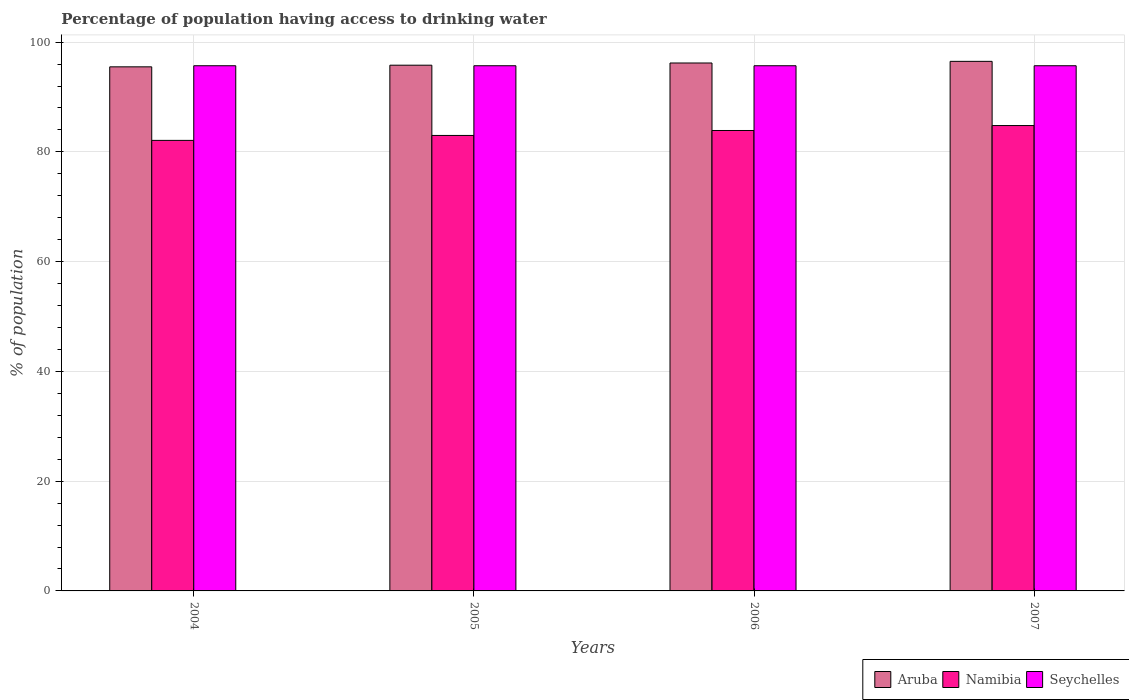How many groups of bars are there?
Your answer should be compact. 4. Are the number of bars on each tick of the X-axis equal?
Offer a very short reply. Yes. How many bars are there on the 4th tick from the left?
Your response must be concise. 3. In how many cases, is the number of bars for a given year not equal to the number of legend labels?
Keep it short and to the point. 0. What is the percentage of population having access to drinking water in Namibia in 2007?
Make the answer very short. 84.8. Across all years, what is the maximum percentage of population having access to drinking water in Namibia?
Your response must be concise. 84.8. Across all years, what is the minimum percentage of population having access to drinking water in Seychelles?
Your answer should be compact. 95.7. In which year was the percentage of population having access to drinking water in Aruba minimum?
Give a very brief answer. 2004. What is the total percentage of population having access to drinking water in Aruba in the graph?
Ensure brevity in your answer.  384. What is the difference between the percentage of population having access to drinking water in Aruba in 2004 and that in 2007?
Give a very brief answer. -1. What is the difference between the percentage of population having access to drinking water in Aruba in 2007 and the percentage of population having access to drinking water in Namibia in 2006?
Ensure brevity in your answer.  12.6. What is the average percentage of population having access to drinking water in Aruba per year?
Offer a very short reply. 96. In the year 2006, what is the difference between the percentage of population having access to drinking water in Namibia and percentage of population having access to drinking water in Seychelles?
Provide a short and direct response. -11.8. In how many years, is the percentage of population having access to drinking water in Seychelles greater than 92 %?
Offer a very short reply. 4. What is the ratio of the percentage of population having access to drinking water in Namibia in 2006 to that in 2007?
Your answer should be compact. 0.99. Is the percentage of population having access to drinking water in Namibia in 2004 less than that in 2007?
Your answer should be compact. Yes. Is the difference between the percentage of population having access to drinking water in Namibia in 2005 and 2006 greater than the difference between the percentage of population having access to drinking water in Seychelles in 2005 and 2006?
Make the answer very short. No. What is the difference between the highest and the second highest percentage of population having access to drinking water in Namibia?
Keep it short and to the point. 0.9. What is the difference between the highest and the lowest percentage of population having access to drinking water in Seychelles?
Ensure brevity in your answer.  0. What does the 2nd bar from the left in 2005 represents?
Your response must be concise. Namibia. What does the 2nd bar from the right in 2004 represents?
Ensure brevity in your answer.  Namibia. How many bars are there?
Provide a succinct answer. 12. How many years are there in the graph?
Your answer should be very brief. 4. Does the graph contain grids?
Offer a terse response. Yes. Where does the legend appear in the graph?
Your response must be concise. Bottom right. How many legend labels are there?
Keep it short and to the point. 3. How are the legend labels stacked?
Your answer should be very brief. Horizontal. What is the title of the graph?
Make the answer very short. Percentage of population having access to drinking water. Does "Slovenia" appear as one of the legend labels in the graph?
Provide a short and direct response. No. What is the label or title of the X-axis?
Offer a terse response. Years. What is the label or title of the Y-axis?
Keep it short and to the point. % of population. What is the % of population in Aruba in 2004?
Provide a succinct answer. 95.5. What is the % of population in Namibia in 2004?
Your answer should be compact. 82.1. What is the % of population of Seychelles in 2004?
Provide a short and direct response. 95.7. What is the % of population of Aruba in 2005?
Your answer should be compact. 95.8. What is the % of population of Seychelles in 2005?
Your response must be concise. 95.7. What is the % of population in Aruba in 2006?
Your response must be concise. 96.2. What is the % of population of Namibia in 2006?
Offer a very short reply. 83.9. What is the % of population of Seychelles in 2006?
Provide a short and direct response. 95.7. What is the % of population in Aruba in 2007?
Offer a very short reply. 96.5. What is the % of population of Namibia in 2007?
Your response must be concise. 84.8. What is the % of population in Seychelles in 2007?
Ensure brevity in your answer.  95.7. Across all years, what is the maximum % of population in Aruba?
Provide a short and direct response. 96.5. Across all years, what is the maximum % of population of Namibia?
Keep it short and to the point. 84.8. Across all years, what is the maximum % of population in Seychelles?
Make the answer very short. 95.7. Across all years, what is the minimum % of population in Aruba?
Offer a very short reply. 95.5. Across all years, what is the minimum % of population in Namibia?
Provide a short and direct response. 82.1. Across all years, what is the minimum % of population in Seychelles?
Offer a terse response. 95.7. What is the total % of population in Aruba in the graph?
Give a very brief answer. 384. What is the total % of population in Namibia in the graph?
Your response must be concise. 333.8. What is the total % of population in Seychelles in the graph?
Your response must be concise. 382.8. What is the difference between the % of population of Aruba in 2004 and that in 2005?
Your response must be concise. -0.3. What is the difference between the % of population of Aruba in 2004 and that in 2006?
Ensure brevity in your answer.  -0.7. What is the difference between the % of population in Namibia in 2004 and that in 2006?
Your answer should be very brief. -1.8. What is the difference between the % of population of Seychelles in 2004 and that in 2006?
Ensure brevity in your answer.  0. What is the difference between the % of population in Namibia in 2004 and that in 2007?
Make the answer very short. -2.7. What is the difference between the % of population of Seychelles in 2004 and that in 2007?
Keep it short and to the point. 0. What is the difference between the % of population in Aruba in 2005 and that in 2006?
Your response must be concise. -0.4. What is the difference between the % of population of Namibia in 2005 and that in 2007?
Provide a succinct answer. -1.8. What is the difference between the % of population in Aruba in 2004 and the % of population in Seychelles in 2005?
Ensure brevity in your answer.  -0.2. What is the difference between the % of population in Namibia in 2004 and the % of population in Seychelles in 2005?
Your answer should be compact. -13.6. What is the difference between the % of population in Aruba in 2004 and the % of population in Namibia in 2006?
Provide a succinct answer. 11.6. What is the difference between the % of population in Aruba in 2004 and the % of population in Seychelles in 2006?
Your response must be concise. -0.2. What is the difference between the % of population of Namibia in 2004 and the % of population of Seychelles in 2006?
Offer a very short reply. -13.6. What is the difference between the % of population in Aruba in 2004 and the % of population in Namibia in 2007?
Give a very brief answer. 10.7. What is the difference between the % of population in Aruba in 2005 and the % of population in Namibia in 2006?
Your answer should be very brief. 11.9. What is the difference between the % of population of Aruba in 2005 and the % of population of Seychelles in 2006?
Your answer should be very brief. 0.1. What is the difference between the % of population in Namibia in 2005 and the % of population in Seychelles in 2006?
Your response must be concise. -12.7. What is the difference between the % of population in Aruba in 2005 and the % of population in Seychelles in 2007?
Ensure brevity in your answer.  0.1. What is the difference between the % of population in Namibia in 2005 and the % of population in Seychelles in 2007?
Ensure brevity in your answer.  -12.7. What is the difference between the % of population in Aruba in 2006 and the % of population in Namibia in 2007?
Your answer should be compact. 11.4. What is the difference between the % of population of Aruba in 2006 and the % of population of Seychelles in 2007?
Your response must be concise. 0.5. What is the difference between the % of population in Namibia in 2006 and the % of population in Seychelles in 2007?
Make the answer very short. -11.8. What is the average % of population of Aruba per year?
Provide a short and direct response. 96. What is the average % of population in Namibia per year?
Ensure brevity in your answer.  83.45. What is the average % of population in Seychelles per year?
Give a very brief answer. 95.7. In the year 2004, what is the difference between the % of population of Aruba and % of population of Namibia?
Provide a short and direct response. 13.4. In the year 2004, what is the difference between the % of population of Aruba and % of population of Seychelles?
Your response must be concise. -0.2. In the year 2004, what is the difference between the % of population of Namibia and % of population of Seychelles?
Offer a terse response. -13.6. In the year 2005, what is the difference between the % of population of Aruba and % of population of Seychelles?
Your answer should be very brief. 0.1. In the year 2005, what is the difference between the % of population of Namibia and % of population of Seychelles?
Offer a terse response. -12.7. In the year 2006, what is the difference between the % of population of Aruba and % of population of Seychelles?
Your answer should be compact. 0.5. In the year 2006, what is the difference between the % of population of Namibia and % of population of Seychelles?
Offer a very short reply. -11.8. In the year 2007, what is the difference between the % of population of Aruba and % of population of Namibia?
Your response must be concise. 11.7. In the year 2007, what is the difference between the % of population of Namibia and % of population of Seychelles?
Your answer should be very brief. -10.9. What is the ratio of the % of population of Aruba in 2004 to that in 2005?
Provide a short and direct response. 1. What is the ratio of the % of population in Namibia in 2004 to that in 2006?
Offer a very short reply. 0.98. What is the ratio of the % of population of Seychelles in 2004 to that in 2006?
Your answer should be compact. 1. What is the ratio of the % of population of Namibia in 2004 to that in 2007?
Ensure brevity in your answer.  0.97. What is the ratio of the % of population in Seychelles in 2004 to that in 2007?
Keep it short and to the point. 1. What is the ratio of the % of population of Namibia in 2005 to that in 2006?
Offer a very short reply. 0.99. What is the ratio of the % of population of Seychelles in 2005 to that in 2006?
Your answer should be compact. 1. What is the ratio of the % of population in Namibia in 2005 to that in 2007?
Provide a short and direct response. 0.98. What is the ratio of the % of population of Aruba in 2006 to that in 2007?
Keep it short and to the point. 1. What is the ratio of the % of population of Namibia in 2006 to that in 2007?
Provide a short and direct response. 0.99. What is the ratio of the % of population of Seychelles in 2006 to that in 2007?
Keep it short and to the point. 1. What is the difference between the highest and the lowest % of population in Aruba?
Provide a succinct answer. 1. What is the difference between the highest and the lowest % of population of Namibia?
Give a very brief answer. 2.7. What is the difference between the highest and the lowest % of population of Seychelles?
Ensure brevity in your answer.  0. 